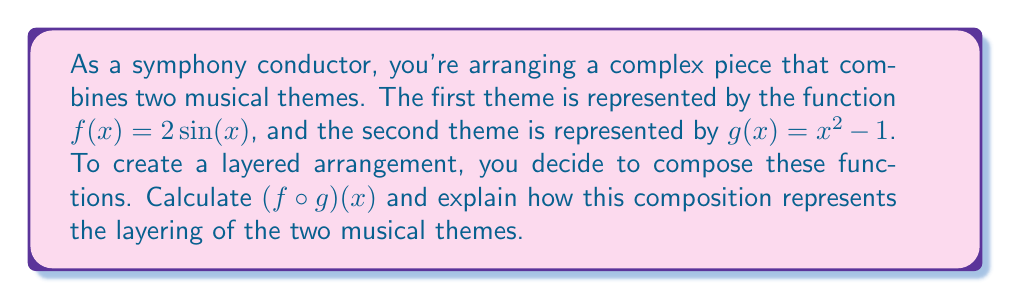Can you solve this math problem? To solve this problem, we need to compose the functions $f(x)$ and $g(x)$. The composition $(f \circ g)(x)$ means we apply function $g$ first, then apply function $f$ to the result.

Step 1: Identify the functions
$f(x) = 2\sin(x)$
$g(x) = x^2 - 1$

Step 2: Compose the functions
$(f \circ g)(x) = f(g(x))$
This means we replace every $x$ in $f(x)$ with $g(x)$:

$$(f \circ g)(x) = 2\sin(g(x)) = 2\sin(x^2 - 1)$$

Step 3: Interpret the result
The resulting function $2\sin(x^2 - 1)$ represents the layered arrangement of the two musical themes:

1. The inner function $x^2 - 1$ (theme 2) is applied first, transforming the original musical line.
2. The outer function $2\sin(x)$ (theme 1) is then applied to this transformed line, creating a new, more complex musical pattern.

This composition creates a unique interplay between the two themes, where the second theme influences the structure of the first theme, resulting in a rich, layered musical arrangement.
Answer: $(f \circ g)(x) = 2\sin(x^2 - 1)$ 